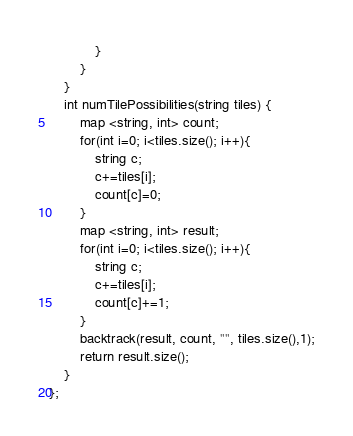Convert code to text. <code><loc_0><loc_0><loc_500><loc_500><_C++_>            }
        }
    }
    int numTilePossibilities(string tiles) {
        map <string, int> count;
        for(int i=0; i<tiles.size(); i++){
            string c;
            c+=tiles[i];
            count[c]=0;
        }
        map <string, int> result;
        for(int i=0; i<tiles.size(); i++){
            string c;
            c+=tiles[i];
            count[c]+=1;
        }
        backtrack(result, count, "", tiles.size(),1);
        return result.size();
    }
};</code> 